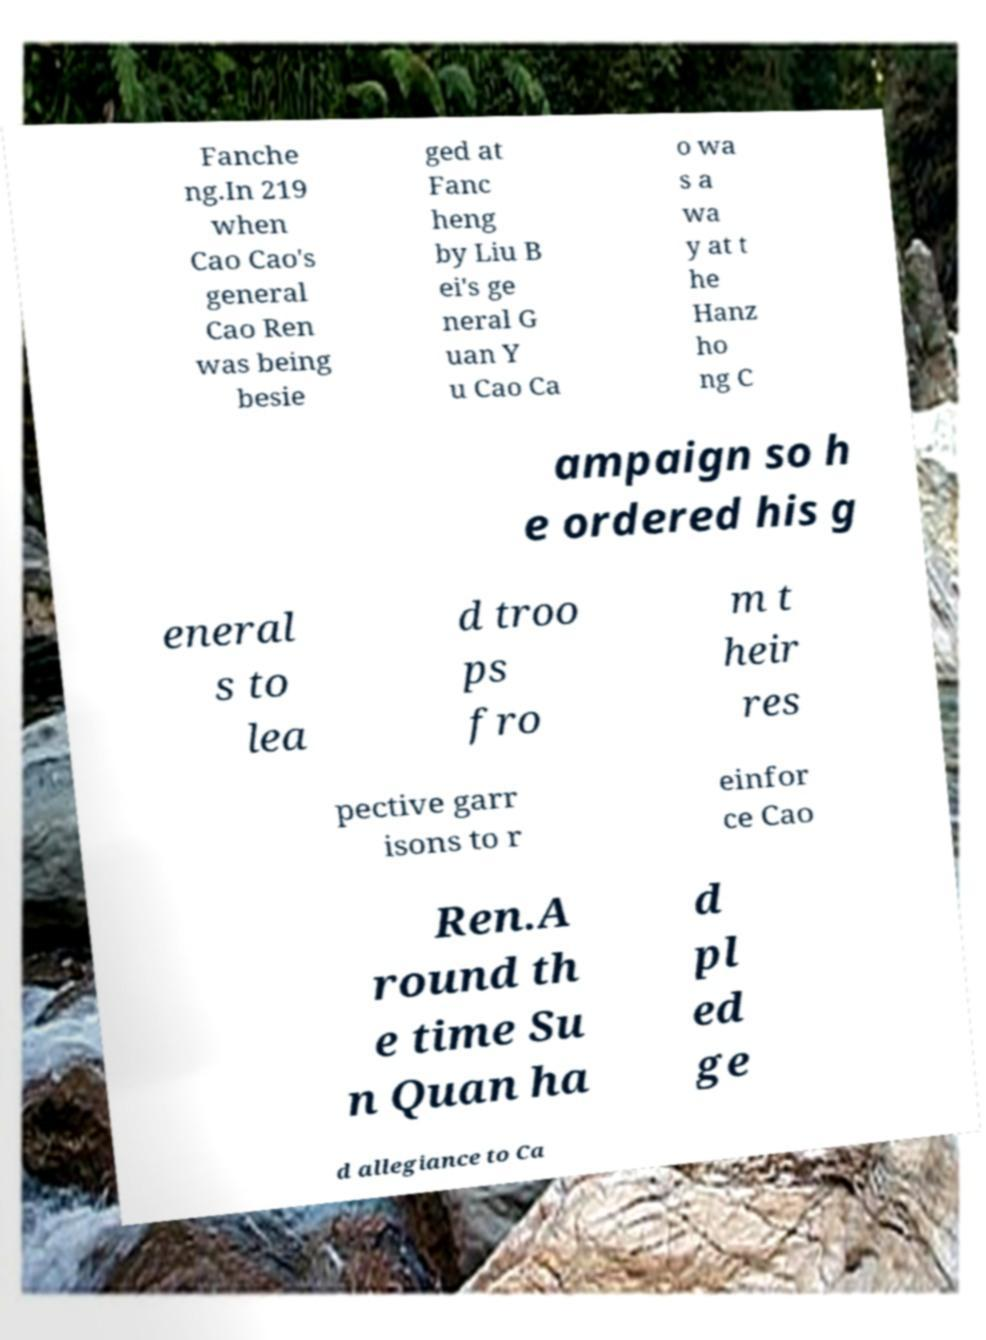There's text embedded in this image that I need extracted. Can you transcribe it verbatim? Fanche ng.In 219 when Cao Cao's general Cao Ren was being besie ged at Fanc heng by Liu B ei's ge neral G uan Y u Cao Ca o wa s a wa y at t he Hanz ho ng C ampaign so h e ordered his g eneral s to lea d troo ps fro m t heir res pective garr isons to r einfor ce Cao Ren.A round th e time Su n Quan ha d pl ed ge d allegiance to Ca 